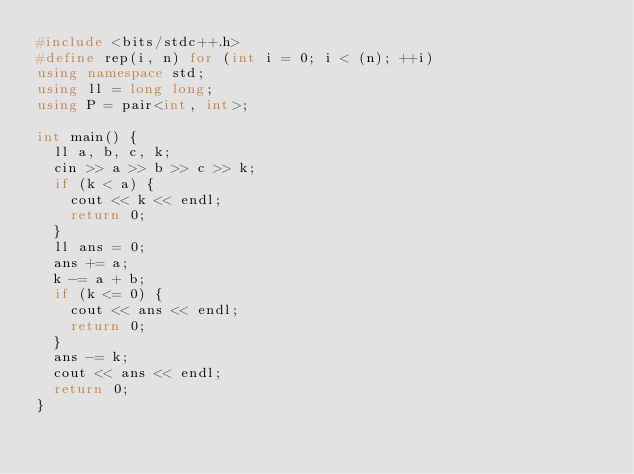Convert code to text. <code><loc_0><loc_0><loc_500><loc_500><_C++_>#include <bits/stdc++.h>
#define rep(i, n) for (int i = 0; i < (n); ++i)
using namespace std;
using ll = long long;
using P = pair<int, int>;

int main() {
  ll a, b, c, k;
  cin >> a >> b >> c >> k;
  if (k < a) {
    cout << k << endl;
    return 0;
  }
  ll ans = 0;
  ans += a;
  k -= a + b;
  if (k <= 0) {
    cout << ans << endl;
    return 0;
  }
  ans -= k;
  cout << ans << endl;
  return 0;
}</code> 